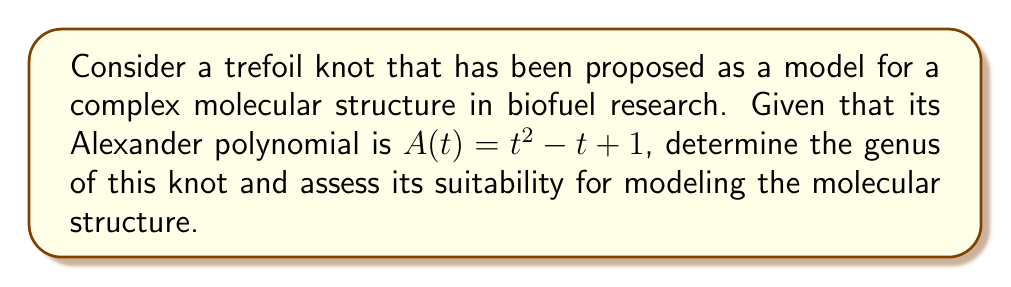Can you answer this question? To determine the genus of the trefoil knot and assess its suitability for modeling complex molecular structures in biofuel research, we'll follow these steps:

1) First, recall the relationship between the Alexander polynomial and the genus of a knot. For any knot K, the degree of its Alexander polynomial A(t) is related to its genus g(K) by the following inequality:

   $$2g(K) \geq \deg(A(t))$$

2) Given the Alexander polynomial $A(t) = t^2 - t + 1$, we can determine its degree:

   $\deg(A(t)) = 2$

3) Substituting this into the inequality:

   $$2g(K) \geq 2$$

4) Solving for g(K):

   $$g(K) \geq 1$$

5) Since the genus must be an integer, and we know the trefoil knot is non-trivial (i.e., not the unknot), we can conclude:

   $$g(K) = 1$$

6) To assess the suitability of this knot for modeling complex molecular structures in biofuel research:

   - A genus-1 knot indicates a relatively simple structure, which might be suitable for modeling basic molecular configurations.
   - However, many complex molecular structures in biofuels might require higher genus knots to accurately represent their intricate spatial arrangements and bonding patterns.
   - The trefoil knot could serve as a starting point for modeling, but may need to be combined with other knots or expanded upon to fully capture the complexity of advanced biofuel molecules.

7) In the context of renewable energy and biofuel research, this model could be useful for:
   - Representing simple sugar molecules or basic hydrocarbon chains
   - Modeling elementary aspects of enzyme-substrate interactions
   - Serving as a building block for more complex molecular models

However, for highly complex structures like cellulose or advanced biocatalysts, higher genus knots or combinations of knots may be necessary.
Answer: Genus: 1; Moderately suitable for basic molecular structures, may need enhancement for complex biofuel molecules. 